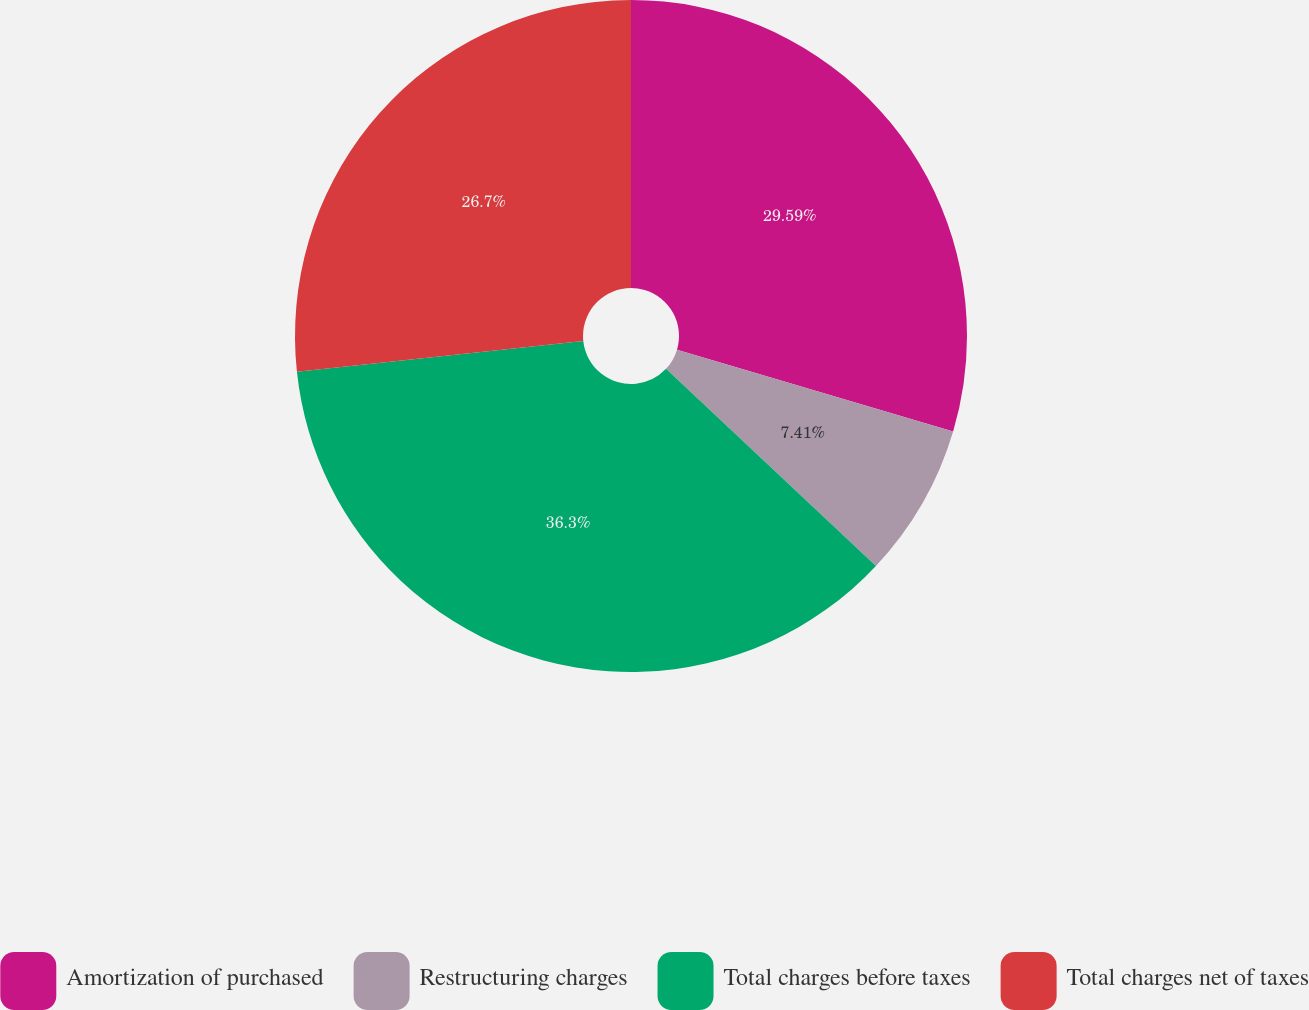Convert chart to OTSL. <chart><loc_0><loc_0><loc_500><loc_500><pie_chart><fcel>Amortization of purchased<fcel>Restructuring charges<fcel>Total charges before taxes<fcel>Total charges net of taxes<nl><fcel>29.59%<fcel>7.41%<fcel>36.3%<fcel>26.7%<nl></chart> 